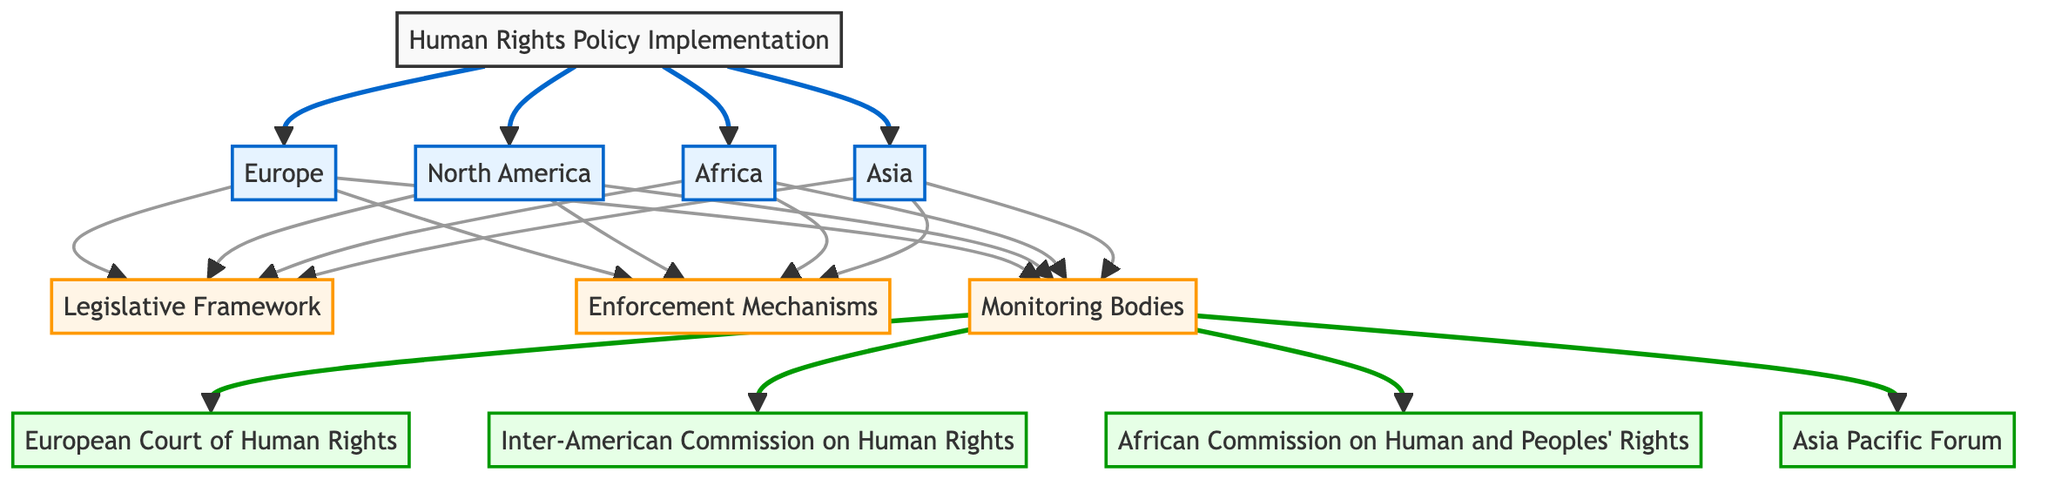What are the four regions represented in the diagram? The diagram shows four regions: Europe, North America, Africa, and Asia, which are indicated as nodes branching from the main topic of Human Rights Policy Implementation.
Answer: Europe, North America, Africa, Asia How many monitoring bodies are listed in the diagram? The diagram lists four monitoring bodies: European Court of Human Rights, Inter-American Commission on Human Rights, African Commission on Human and Peoples' Rights, and Asia Pacific Forum, indicating the total by counting the unique nodes connected to Monitoring Bodies.
Answer: 4 What are the components that connect to all regions? The components that connect to all regions are Legislative Framework, Enforcement Mechanisms, and Monitoring Bodies, which are common to each regional branch in the diagram.
Answer: Legislative Framework, Enforcement Mechanisms, Monitoring Bodies Which region has a direct link to the European Court of Human Rights? The region Europe has a direct link to the European Court of Human Rights, as shown by the connecting arrows originating from the Europe node to the Monitoring Bodies section.
Answer: Europe What is the relationship between the Enforcement Mechanisms and the regions? All four regions (Europe, North America, Africa, Asia) connect to the Enforcement Mechanisms component, implying that each region incorporates these mechanisms into their human rights policy implementation.
Answer: All four regions connect Which monitoring body is associated with North America? The Inter-American Commission on Human Rights is associated with North America, shown by the direct link from the North America region node to the Monitoring Bodies, specifically to the Inter-American Commission node.
Answer: Inter-American Commission on Human Rights How many edges lead from the Human Rights Policy Implementation node? There are four edges leading from the Human Rights Policy Implementation node, one for each region (Europe, North America, Africa, Asia), representing the connections to the regional nodes from the main policy implementation node.
Answer: 4 What is the significance of the Monitoring Bodies in the diagram? The Monitoring Bodies are depicted as an essential component connected to each region's Enforcement Mechanisms, indicating their role in overseeing and ensuring the adherence to human rights policies across all represented regions.
Answer: Oversight of human rights policies Which region has no unique monitoring body listed in the diagram? Asia does not have a unique monitoring body listed in the diagram as it is grouped under the Asia Pacific Forum, which is one of the multiple monitoring bodies applicable to various regions.
Answer: Asia 